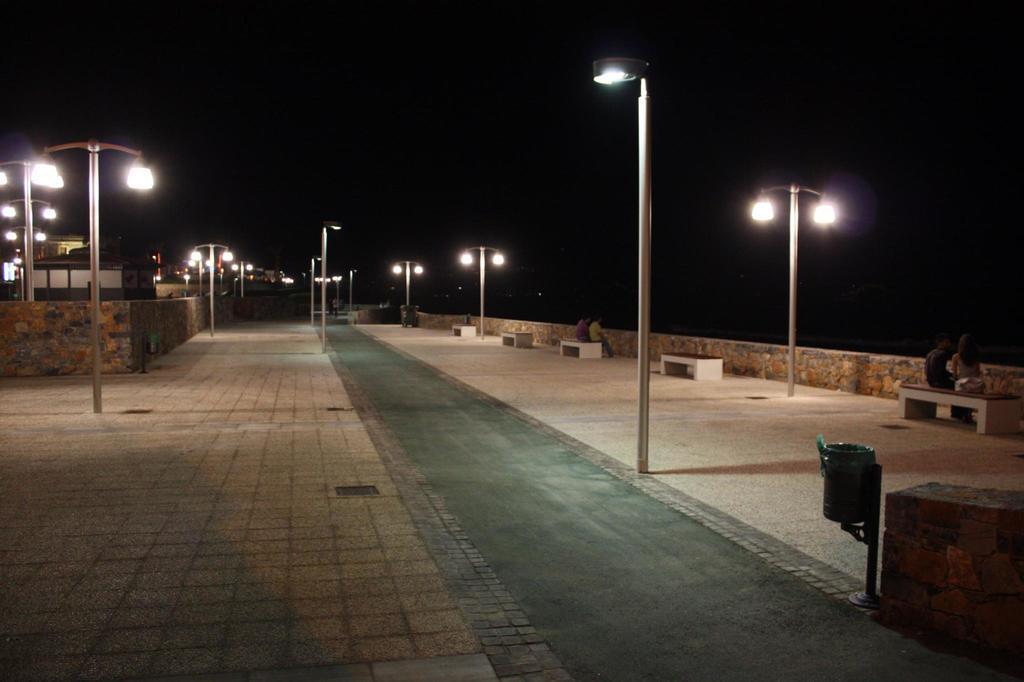Can you describe this image briefly? This picture is clicked outside. On the right we can see the group of persons sitting on the benches and we can see the lights are attached to the poles, we can see the pavement and some houses. In the background there is a sky. 